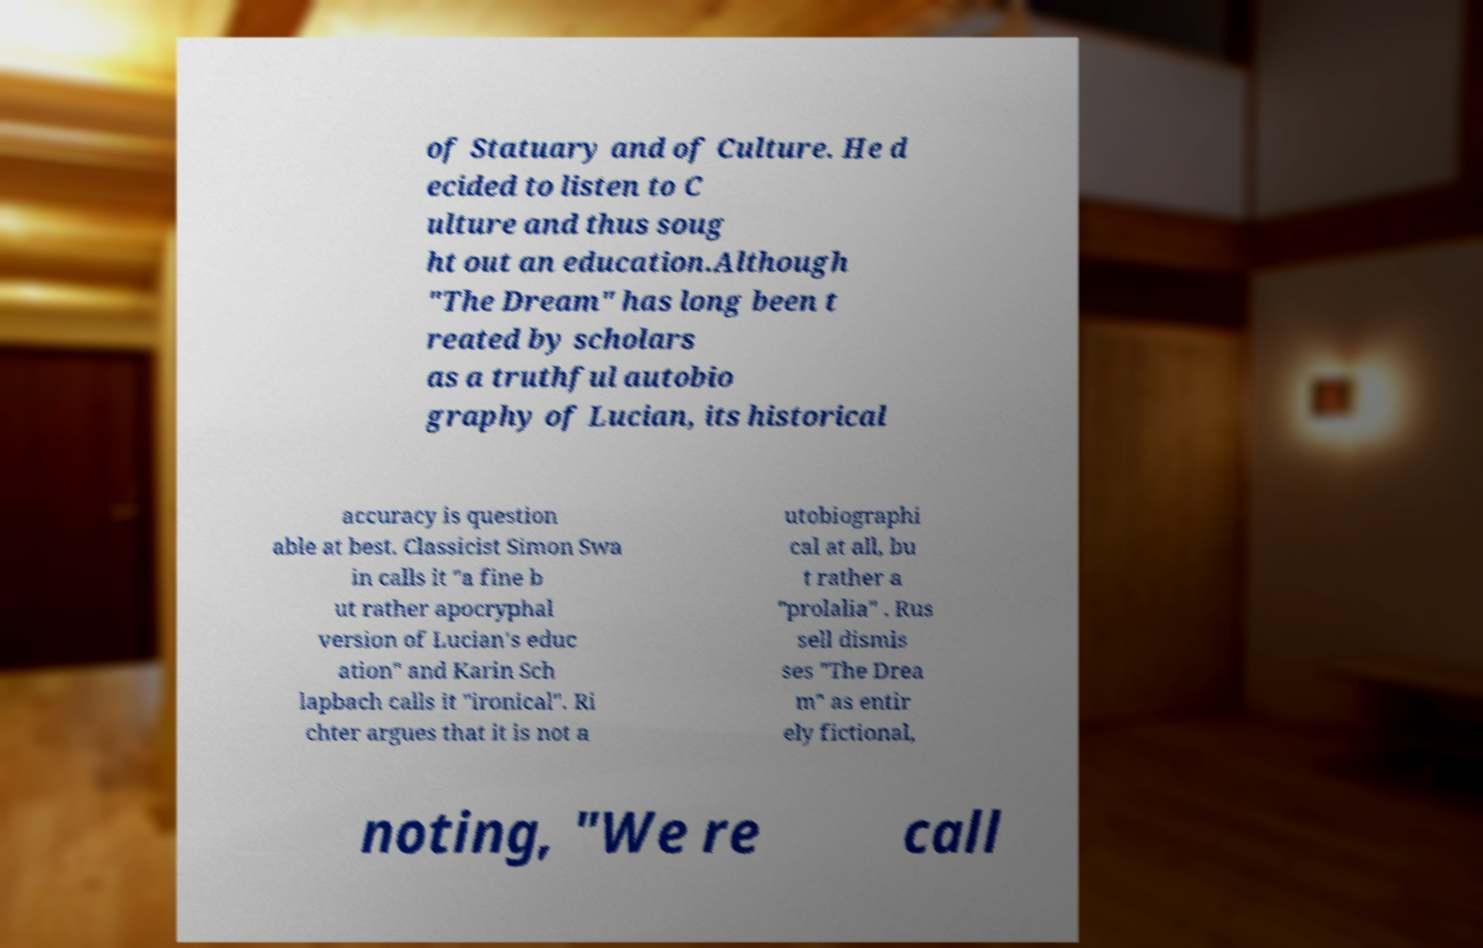Please read and relay the text visible in this image. What does it say? of Statuary and of Culture. He d ecided to listen to C ulture and thus soug ht out an education.Although "The Dream" has long been t reated by scholars as a truthful autobio graphy of Lucian, its historical accuracy is question able at best. Classicist Simon Swa in calls it "a fine b ut rather apocryphal version of Lucian's educ ation" and Karin Sch lapbach calls it "ironical". Ri chter argues that it is not a utobiographi cal at all, bu t rather a "prolalia" . Rus sell dismis ses "The Drea m" as entir ely fictional, noting, "We re call 